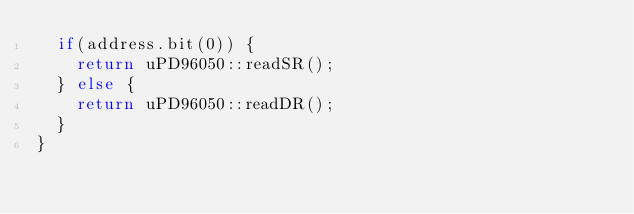Convert code to text. <code><loc_0><loc_0><loc_500><loc_500><_C++_>  if(address.bit(0)) {
    return uPD96050::readSR();
  } else {
    return uPD96050::readDR();
  }
}
</code> 